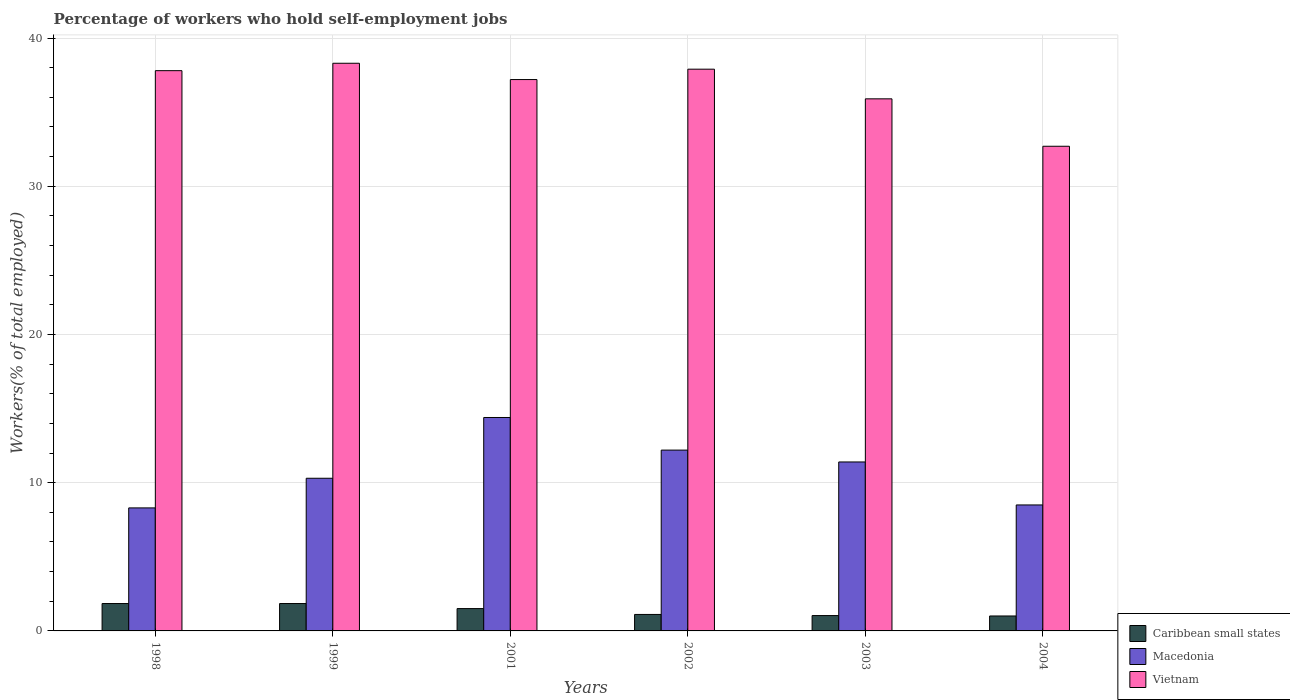How many different coloured bars are there?
Offer a very short reply. 3. How many groups of bars are there?
Offer a terse response. 6. Are the number of bars per tick equal to the number of legend labels?
Offer a very short reply. Yes. How many bars are there on the 4th tick from the left?
Give a very brief answer. 3. What is the label of the 6th group of bars from the left?
Keep it short and to the point. 2004. What is the percentage of self-employed workers in Caribbean small states in 1998?
Offer a terse response. 1.85. Across all years, what is the maximum percentage of self-employed workers in Caribbean small states?
Provide a short and direct response. 1.85. Across all years, what is the minimum percentage of self-employed workers in Caribbean small states?
Offer a very short reply. 1.01. What is the total percentage of self-employed workers in Macedonia in the graph?
Make the answer very short. 65.1. What is the difference between the percentage of self-employed workers in Macedonia in 2002 and that in 2003?
Keep it short and to the point. 0.8. What is the difference between the percentage of self-employed workers in Caribbean small states in 2003 and the percentage of self-employed workers in Macedonia in 2001?
Offer a terse response. -13.36. What is the average percentage of self-employed workers in Macedonia per year?
Offer a terse response. 10.85. In the year 2002, what is the difference between the percentage of self-employed workers in Caribbean small states and percentage of self-employed workers in Vietnam?
Give a very brief answer. -36.79. What is the ratio of the percentage of self-employed workers in Macedonia in 1999 to that in 2002?
Provide a short and direct response. 0.84. What is the difference between the highest and the second highest percentage of self-employed workers in Vietnam?
Provide a short and direct response. 0.4. What is the difference between the highest and the lowest percentage of self-employed workers in Caribbean small states?
Keep it short and to the point. 0.84. In how many years, is the percentage of self-employed workers in Macedonia greater than the average percentage of self-employed workers in Macedonia taken over all years?
Give a very brief answer. 3. Is the sum of the percentage of self-employed workers in Caribbean small states in 1998 and 2001 greater than the maximum percentage of self-employed workers in Macedonia across all years?
Make the answer very short. No. What does the 1st bar from the left in 2004 represents?
Give a very brief answer. Caribbean small states. What does the 2nd bar from the right in 1999 represents?
Offer a very short reply. Macedonia. How many years are there in the graph?
Provide a succinct answer. 6. What is the difference between two consecutive major ticks on the Y-axis?
Keep it short and to the point. 10. Does the graph contain any zero values?
Make the answer very short. No. Does the graph contain grids?
Make the answer very short. Yes. How many legend labels are there?
Offer a very short reply. 3. How are the legend labels stacked?
Your response must be concise. Vertical. What is the title of the graph?
Provide a succinct answer. Percentage of workers who hold self-employment jobs. Does "Lithuania" appear as one of the legend labels in the graph?
Offer a terse response. No. What is the label or title of the X-axis?
Your answer should be very brief. Years. What is the label or title of the Y-axis?
Your response must be concise. Workers(% of total employed). What is the Workers(% of total employed) in Caribbean small states in 1998?
Provide a succinct answer. 1.85. What is the Workers(% of total employed) of Macedonia in 1998?
Your answer should be compact. 8.3. What is the Workers(% of total employed) of Vietnam in 1998?
Offer a terse response. 37.8. What is the Workers(% of total employed) in Caribbean small states in 1999?
Make the answer very short. 1.85. What is the Workers(% of total employed) in Macedonia in 1999?
Your answer should be very brief. 10.3. What is the Workers(% of total employed) of Vietnam in 1999?
Provide a succinct answer. 38.3. What is the Workers(% of total employed) in Caribbean small states in 2001?
Provide a succinct answer. 1.51. What is the Workers(% of total employed) of Macedonia in 2001?
Ensure brevity in your answer.  14.4. What is the Workers(% of total employed) in Vietnam in 2001?
Give a very brief answer. 37.2. What is the Workers(% of total employed) in Caribbean small states in 2002?
Ensure brevity in your answer.  1.11. What is the Workers(% of total employed) in Macedonia in 2002?
Your response must be concise. 12.2. What is the Workers(% of total employed) in Vietnam in 2002?
Keep it short and to the point. 37.9. What is the Workers(% of total employed) of Caribbean small states in 2003?
Ensure brevity in your answer.  1.04. What is the Workers(% of total employed) of Macedonia in 2003?
Keep it short and to the point. 11.4. What is the Workers(% of total employed) of Vietnam in 2003?
Your response must be concise. 35.9. What is the Workers(% of total employed) of Caribbean small states in 2004?
Make the answer very short. 1.01. What is the Workers(% of total employed) in Macedonia in 2004?
Ensure brevity in your answer.  8.5. What is the Workers(% of total employed) in Vietnam in 2004?
Provide a short and direct response. 32.7. Across all years, what is the maximum Workers(% of total employed) in Caribbean small states?
Ensure brevity in your answer.  1.85. Across all years, what is the maximum Workers(% of total employed) of Macedonia?
Give a very brief answer. 14.4. Across all years, what is the maximum Workers(% of total employed) of Vietnam?
Your response must be concise. 38.3. Across all years, what is the minimum Workers(% of total employed) of Caribbean small states?
Provide a short and direct response. 1.01. Across all years, what is the minimum Workers(% of total employed) in Macedonia?
Your response must be concise. 8.3. Across all years, what is the minimum Workers(% of total employed) of Vietnam?
Offer a very short reply. 32.7. What is the total Workers(% of total employed) in Caribbean small states in the graph?
Keep it short and to the point. 8.36. What is the total Workers(% of total employed) in Macedonia in the graph?
Give a very brief answer. 65.1. What is the total Workers(% of total employed) of Vietnam in the graph?
Your answer should be very brief. 219.8. What is the difference between the Workers(% of total employed) of Caribbean small states in 1998 and that in 1999?
Your response must be concise. -0. What is the difference between the Workers(% of total employed) of Vietnam in 1998 and that in 1999?
Your answer should be very brief. -0.5. What is the difference between the Workers(% of total employed) in Caribbean small states in 1998 and that in 2001?
Give a very brief answer. 0.34. What is the difference between the Workers(% of total employed) in Caribbean small states in 1998 and that in 2002?
Make the answer very short. 0.74. What is the difference between the Workers(% of total employed) of Caribbean small states in 1998 and that in 2003?
Provide a succinct answer. 0.81. What is the difference between the Workers(% of total employed) in Caribbean small states in 1998 and that in 2004?
Your answer should be very brief. 0.84. What is the difference between the Workers(% of total employed) of Vietnam in 1998 and that in 2004?
Give a very brief answer. 5.1. What is the difference between the Workers(% of total employed) in Caribbean small states in 1999 and that in 2001?
Your answer should be compact. 0.34. What is the difference between the Workers(% of total employed) in Caribbean small states in 1999 and that in 2002?
Ensure brevity in your answer.  0.74. What is the difference between the Workers(% of total employed) in Macedonia in 1999 and that in 2002?
Keep it short and to the point. -1.9. What is the difference between the Workers(% of total employed) of Caribbean small states in 1999 and that in 2003?
Ensure brevity in your answer.  0.81. What is the difference between the Workers(% of total employed) of Caribbean small states in 1999 and that in 2004?
Provide a short and direct response. 0.84. What is the difference between the Workers(% of total employed) in Macedonia in 1999 and that in 2004?
Make the answer very short. 1.8. What is the difference between the Workers(% of total employed) of Caribbean small states in 2001 and that in 2002?
Provide a succinct answer. 0.4. What is the difference between the Workers(% of total employed) of Macedonia in 2001 and that in 2002?
Your response must be concise. 2.2. What is the difference between the Workers(% of total employed) in Caribbean small states in 2001 and that in 2003?
Give a very brief answer. 0.47. What is the difference between the Workers(% of total employed) in Vietnam in 2001 and that in 2003?
Provide a short and direct response. 1.3. What is the difference between the Workers(% of total employed) of Caribbean small states in 2001 and that in 2004?
Your answer should be compact. 0.5. What is the difference between the Workers(% of total employed) in Macedonia in 2001 and that in 2004?
Offer a very short reply. 5.9. What is the difference between the Workers(% of total employed) of Caribbean small states in 2002 and that in 2003?
Keep it short and to the point. 0.08. What is the difference between the Workers(% of total employed) in Macedonia in 2002 and that in 2003?
Give a very brief answer. 0.8. What is the difference between the Workers(% of total employed) in Caribbean small states in 2002 and that in 2004?
Ensure brevity in your answer.  0.1. What is the difference between the Workers(% of total employed) of Macedonia in 2002 and that in 2004?
Keep it short and to the point. 3.7. What is the difference between the Workers(% of total employed) in Vietnam in 2002 and that in 2004?
Keep it short and to the point. 5.2. What is the difference between the Workers(% of total employed) of Caribbean small states in 2003 and that in 2004?
Give a very brief answer. 0.03. What is the difference between the Workers(% of total employed) of Macedonia in 2003 and that in 2004?
Offer a very short reply. 2.9. What is the difference between the Workers(% of total employed) in Caribbean small states in 1998 and the Workers(% of total employed) in Macedonia in 1999?
Your response must be concise. -8.45. What is the difference between the Workers(% of total employed) of Caribbean small states in 1998 and the Workers(% of total employed) of Vietnam in 1999?
Provide a succinct answer. -36.45. What is the difference between the Workers(% of total employed) in Caribbean small states in 1998 and the Workers(% of total employed) in Macedonia in 2001?
Your answer should be very brief. -12.55. What is the difference between the Workers(% of total employed) in Caribbean small states in 1998 and the Workers(% of total employed) in Vietnam in 2001?
Provide a short and direct response. -35.35. What is the difference between the Workers(% of total employed) in Macedonia in 1998 and the Workers(% of total employed) in Vietnam in 2001?
Ensure brevity in your answer.  -28.9. What is the difference between the Workers(% of total employed) of Caribbean small states in 1998 and the Workers(% of total employed) of Macedonia in 2002?
Your answer should be compact. -10.35. What is the difference between the Workers(% of total employed) of Caribbean small states in 1998 and the Workers(% of total employed) of Vietnam in 2002?
Offer a terse response. -36.05. What is the difference between the Workers(% of total employed) of Macedonia in 1998 and the Workers(% of total employed) of Vietnam in 2002?
Your answer should be very brief. -29.6. What is the difference between the Workers(% of total employed) in Caribbean small states in 1998 and the Workers(% of total employed) in Macedonia in 2003?
Your answer should be very brief. -9.55. What is the difference between the Workers(% of total employed) in Caribbean small states in 1998 and the Workers(% of total employed) in Vietnam in 2003?
Your answer should be very brief. -34.05. What is the difference between the Workers(% of total employed) in Macedonia in 1998 and the Workers(% of total employed) in Vietnam in 2003?
Give a very brief answer. -27.6. What is the difference between the Workers(% of total employed) in Caribbean small states in 1998 and the Workers(% of total employed) in Macedonia in 2004?
Keep it short and to the point. -6.65. What is the difference between the Workers(% of total employed) of Caribbean small states in 1998 and the Workers(% of total employed) of Vietnam in 2004?
Give a very brief answer. -30.85. What is the difference between the Workers(% of total employed) of Macedonia in 1998 and the Workers(% of total employed) of Vietnam in 2004?
Ensure brevity in your answer.  -24.4. What is the difference between the Workers(% of total employed) of Caribbean small states in 1999 and the Workers(% of total employed) of Macedonia in 2001?
Your answer should be compact. -12.55. What is the difference between the Workers(% of total employed) of Caribbean small states in 1999 and the Workers(% of total employed) of Vietnam in 2001?
Provide a short and direct response. -35.35. What is the difference between the Workers(% of total employed) in Macedonia in 1999 and the Workers(% of total employed) in Vietnam in 2001?
Give a very brief answer. -26.9. What is the difference between the Workers(% of total employed) in Caribbean small states in 1999 and the Workers(% of total employed) in Macedonia in 2002?
Make the answer very short. -10.35. What is the difference between the Workers(% of total employed) in Caribbean small states in 1999 and the Workers(% of total employed) in Vietnam in 2002?
Provide a succinct answer. -36.05. What is the difference between the Workers(% of total employed) of Macedonia in 1999 and the Workers(% of total employed) of Vietnam in 2002?
Provide a succinct answer. -27.6. What is the difference between the Workers(% of total employed) of Caribbean small states in 1999 and the Workers(% of total employed) of Macedonia in 2003?
Provide a short and direct response. -9.55. What is the difference between the Workers(% of total employed) of Caribbean small states in 1999 and the Workers(% of total employed) of Vietnam in 2003?
Keep it short and to the point. -34.05. What is the difference between the Workers(% of total employed) of Macedonia in 1999 and the Workers(% of total employed) of Vietnam in 2003?
Your answer should be compact. -25.6. What is the difference between the Workers(% of total employed) of Caribbean small states in 1999 and the Workers(% of total employed) of Macedonia in 2004?
Ensure brevity in your answer.  -6.65. What is the difference between the Workers(% of total employed) of Caribbean small states in 1999 and the Workers(% of total employed) of Vietnam in 2004?
Keep it short and to the point. -30.85. What is the difference between the Workers(% of total employed) in Macedonia in 1999 and the Workers(% of total employed) in Vietnam in 2004?
Your answer should be compact. -22.4. What is the difference between the Workers(% of total employed) of Caribbean small states in 2001 and the Workers(% of total employed) of Macedonia in 2002?
Keep it short and to the point. -10.69. What is the difference between the Workers(% of total employed) of Caribbean small states in 2001 and the Workers(% of total employed) of Vietnam in 2002?
Your answer should be compact. -36.39. What is the difference between the Workers(% of total employed) in Macedonia in 2001 and the Workers(% of total employed) in Vietnam in 2002?
Ensure brevity in your answer.  -23.5. What is the difference between the Workers(% of total employed) in Caribbean small states in 2001 and the Workers(% of total employed) in Macedonia in 2003?
Offer a terse response. -9.89. What is the difference between the Workers(% of total employed) of Caribbean small states in 2001 and the Workers(% of total employed) of Vietnam in 2003?
Ensure brevity in your answer.  -34.39. What is the difference between the Workers(% of total employed) of Macedonia in 2001 and the Workers(% of total employed) of Vietnam in 2003?
Ensure brevity in your answer.  -21.5. What is the difference between the Workers(% of total employed) of Caribbean small states in 2001 and the Workers(% of total employed) of Macedonia in 2004?
Provide a succinct answer. -6.99. What is the difference between the Workers(% of total employed) in Caribbean small states in 2001 and the Workers(% of total employed) in Vietnam in 2004?
Offer a very short reply. -31.19. What is the difference between the Workers(% of total employed) in Macedonia in 2001 and the Workers(% of total employed) in Vietnam in 2004?
Provide a succinct answer. -18.3. What is the difference between the Workers(% of total employed) in Caribbean small states in 2002 and the Workers(% of total employed) in Macedonia in 2003?
Ensure brevity in your answer.  -10.29. What is the difference between the Workers(% of total employed) of Caribbean small states in 2002 and the Workers(% of total employed) of Vietnam in 2003?
Offer a terse response. -34.79. What is the difference between the Workers(% of total employed) of Macedonia in 2002 and the Workers(% of total employed) of Vietnam in 2003?
Your response must be concise. -23.7. What is the difference between the Workers(% of total employed) in Caribbean small states in 2002 and the Workers(% of total employed) in Macedonia in 2004?
Provide a short and direct response. -7.39. What is the difference between the Workers(% of total employed) of Caribbean small states in 2002 and the Workers(% of total employed) of Vietnam in 2004?
Your answer should be compact. -31.59. What is the difference between the Workers(% of total employed) in Macedonia in 2002 and the Workers(% of total employed) in Vietnam in 2004?
Provide a short and direct response. -20.5. What is the difference between the Workers(% of total employed) of Caribbean small states in 2003 and the Workers(% of total employed) of Macedonia in 2004?
Give a very brief answer. -7.46. What is the difference between the Workers(% of total employed) in Caribbean small states in 2003 and the Workers(% of total employed) in Vietnam in 2004?
Offer a very short reply. -31.66. What is the difference between the Workers(% of total employed) of Macedonia in 2003 and the Workers(% of total employed) of Vietnam in 2004?
Your response must be concise. -21.3. What is the average Workers(% of total employed) of Caribbean small states per year?
Your answer should be very brief. 1.39. What is the average Workers(% of total employed) of Macedonia per year?
Give a very brief answer. 10.85. What is the average Workers(% of total employed) in Vietnam per year?
Offer a terse response. 36.63. In the year 1998, what is the difference between the Workers(% of total employed) in Caribbean small states and Workers(% of total employed) in Macedonia?
Offer a terse response. -6.45. In the year 1998, what is the difference between the Workers(% of total employed) in Caribbean small states and Workers(% of total employed) in Vietnam?
Make the answer very short. -35.95. In the year 1998, what is the difference between the Workers(% of total employed) in Macedonia and Workers(% of total employed) in Vietnam?
Offer a very short reply. -29.5. In the year 1999, what is the difference between the Workers(% of total employed) of Caribbean small states and Workers(% of total employed) of Macedonia?
Your response must be concise. -8.45. In the year 1999, what is the difference between the Workers(% of total employed) of Caribbean small states and Workers(% of total employed) of Vietnam?
Keep it short and to the point. -36.45. In the year 2001, what is the difference between the Workers(% of total employed) in Caribbean small states and Workers(% of total employed) in Macedonia?
Offer a terse response. -12.89. In the year 2001, what is the difference between the Workers(% of total employed) in Caribbean small states and Workers(% of total employed) in Vietnam?
Provide a succinct answer. -35.69. In the year 2001, what is the difference between the Workers(% of total employed) of Macedonia and Workers(% of total employed) of Vietnam?
Your answer should be compact. -22.8. In the year 2002, what is the difference between the Workers(% of total employed) in Caribbean small states and Workers(% of total employed) in Macedonia?
Give a very brief answer. -11.09. In the year 2002, what is the difference between the Workers(% of total employed) of Caribbean small states and Workers(% of total employed) of Vietnam?
Make the answer very short. -36.79. In the year 2002, what is the difference between the Workers(% of total employed) of Macedonia and Workers(% of total employed) of Vietnam?
Provide a succinct answer. -25.7. In the year 2003, what is the difference between the Workers(% of total employed) in Caribbean small states and Workers(% of total employed) in Macedonia?
Offer a terse response. -10.36. In the year 2003, what is the difference between the Workers(% of total employed) in Caribbean small states and Workers(% of total employed) in Vietnam?
Ensure brevity in your answer.  -34.86. In the year 2003, what is the difference between the Workers(% of total employed) in Macedonia and Workers(% of total employed) in Vietnam?
Your answer should be very brief. -24.5. In the year 2004, what is the difference between the Workers(% of total employed) of Caribbean small states and Workers(% of total employed) of Macedonia?
Ensure brevity in your answer.  -7.49. In the year 2004, what is the difference between the Workers(% of total employed) of Caribbean small states and Workers(% of total employed) of Vietnam?
Ensure brevity in your answer.  -31.69. In the year 2004, what is the difference between the Workers(% of total employed) of Macedonia and Workers(% of total employed) of Vietnam?
Your response must be concise. -24.2. What is the ratio of the Workers(% of total employed) in Macedonia in 1998 to that in 1999?
Your answer should be very brief. 0.81. What is the ratio of the Workers(% of total employed) in Vietnam in 1998 to that in 1999?
Offer a terse response. 0.99. What is the ratio of the Workers(% of total employed) in Caribbean small states in 1998 to that in 2001?
Offer a very short reply. 1.23. What is the ratio of the Workers(% of total employed) of Macedonia in 1998 to that in 2001?
Offer a terse response. 0.58. What is the ratio of the Workers(% of total employed) in Vietnam in 1998 to that in 2001?
Provide a succinct answer. 1.02. What is the ratio of the Workers(% of total employed) of Caribbean small states in 1998 to that in 2002?
Keep it short and to the point. 1.66. What is the ratio of the Workers(% of total employed) of Macedonia in 1998 to that in 2002?
Provide a succinct answer. 0.68. What is the ratio of the Workers(% of total employed) in Vietnam in 1998 to that in 2002?
Give a very brief answer. 1. What is the ratio of the Workers(% of total employed) in Caribbean small states in 1998 to that in 2003?
Your answer should be very brief. 1.78. What is the ratio of the Workers(% of total employed) in Macedonia in 1998 to that in 2003?
Keep it short and to the point. 0.73. What is the ratio of the Workers(% of total employed) of Vietnam in 1998 to that in 2003?
Your answer should be compact. 1.05. What is the ratio of the Workers(% of total employed) in Caribbean small states in 1998 to that in 2004?
Offer a terse response. 1.83. What is the ratio of the Workers(% of total employed) in Macedonia in 1998 to that in 2004?
Your response must be concise. 0.98. What is the ratio of the Workers(% of total employed) in Vietnam in 1998 to that in 2004?
Offer a very short reply. 1.16. What is the ratio of the Workers(% of total employed) in Caribbean small states in 1999 to that in 2001?
Keep it short and to the point. 1.23. What is the ratio of the Workers(% of total employed) in Macedonia in 1999 to that in 2001?
Offer a terse response. 0.72. What is the ratio of the Workers(% of total employed) of Vietnam in 1999 to that in 2001?
Your answer should be compact. 1.03. What is the ratio of the Workers(% of total employed) in Caribbean small states in 1999 to that in 2002?
Offer a terse response. 1.66. What is the ratio of the Workers(% of total employed) in Macedonia in 1999 to that in 2002?
Keep it short and to the point. 0.84. What is the ratio of the Workers(% of total employed) of Vietnam in 1999 to that in 2002?
Your answer should be compact. 1.01. What is the ratio of the Workers(% of total employed) in Caribbean small states in 1999 to that in 2003?
Give a very brief answer. 1.78. What is the ratio of the Workers(% of total employed) of Macedonia in 1999 to that in 2003?
Provide a short and direct response. 0.9. What is the ratio of the Workers(% of total employed) in Vietnam in 1999 to that in 2003?
Offer a terse response. 1.07. What is the ratio of the Workers(% of total employed) of Caribbean small states in 1999 to that in 2004?
Your response must be concise. 1.83. What is the ratio of the Workers(% of total employed) of Macedonia in 1999 to that in 2004?
Make the answer very short. 1.21. What is the ratio of the Workers(% of total employed) of Vietnam in 1999 to that in 2004?
Your answer should be compact. 1.17. What is the ratio of the Workers(% of total employed) in Caribbean small states in 2001 to that in 2002?
Your answer should be very brief. 1.36. What is the ratio of the Workers(% of total employed) in Macedonia in 2001 to that in 2002?
Provide a succinct answer. 1.18. What is the ratio of the Workers(% of total employed) in Vietnam in 2001 to that in 2002?
Offer a terse response. 0.98. What is the ratio of the Workers(% of total employed) in Caribbean small states in 2001 to that in 2003?
Ensure brevity in your answer.  1.46. What is the ratio of the Workers(% of total employed) of Macedonia in 2001 to that in 2003?
Your answer should be compact. 1.26. What is the ratio of the Workers(% of total employed) in Vietnam in 2001 to that in 2003?
Make the answer very short. 1.04. What is the ratio of the Workers(% of total employed) of Caribbean small states in 2001 to that in 2004?
Keep it short and to the point. 1.49. What is the ratio of the Workers(% of total employed) in Macedonia in 2001 to that in 2004?
Your answer should be compact. 1.69. What is the ratio of the Workers(% of total employed) in Vietnam in 2001 to that in 2004?
Your response must be concise. 1.14. What is the ratio of the Workers(% of total employed) in Caribbean small states in 2002 to that in 2003?
Your response must be concise. 1.07. What is the ratio of the Workers(% of total employed) in Macedonia in 2002 to that in 2003?
Ensure brevity in your answer.  1.07. What is the ratio of the Workers(% of total employed) in Vietnam in 2002 to that in 2003?
Keep it short and to the point. 1.06. What is the ratio of the Workers(% of total employed) of Caribbean small states in 2002 to that in 2004?
Make the answer very short. 1.1. What is the ratio of the Workers(% of total employed) of Macedonia in 2002 to that in 2004?
Your answer should be compact. 1.44. What is the ratio of the Workers(% of total employed) in Vietnam in 2002 to that in 2004?
Make the answer very short. 1.16. What is the ratio of the Workers(% of total employed) in Caribbean small states in 2003 to that in 2004?
Offer a very short reply. 1.03. What is the ratio of the Workers(% of total employed) in Macedonia in 2003 to that in 2004?
Your answer should be very brief. 1.34. What is the ratio of the Workers(% of total employed) in Vietnam in 2003 to that in 2004?
Give a very brief answer. 1.1. What is the difference between the highest and the lowest Workers(% of total employed) in Caribbean small states?
Offer a very short reply. 0.84. What is the difference between the highest and the lowest Workers(% of total employed) of Macedonia?
Make the answer very short. 6.1. What is the difference between the highest and the lowest Workers(% of total employed) of Vietnam?
Give a very brief answer. 5.6. 